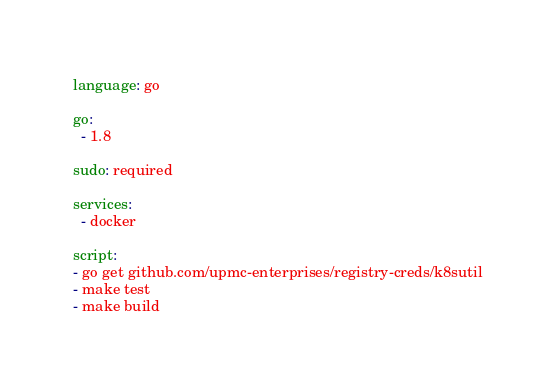<code> <loc_0><loc_0><loc_500><loc_500><_YAML_>language: go

go:
  - 1.8

sudo: required

services:
  - docker

script:
- go get github.com/upmc-enterprises/registry-creds/k8sutil
- make test
- make build
</code> 